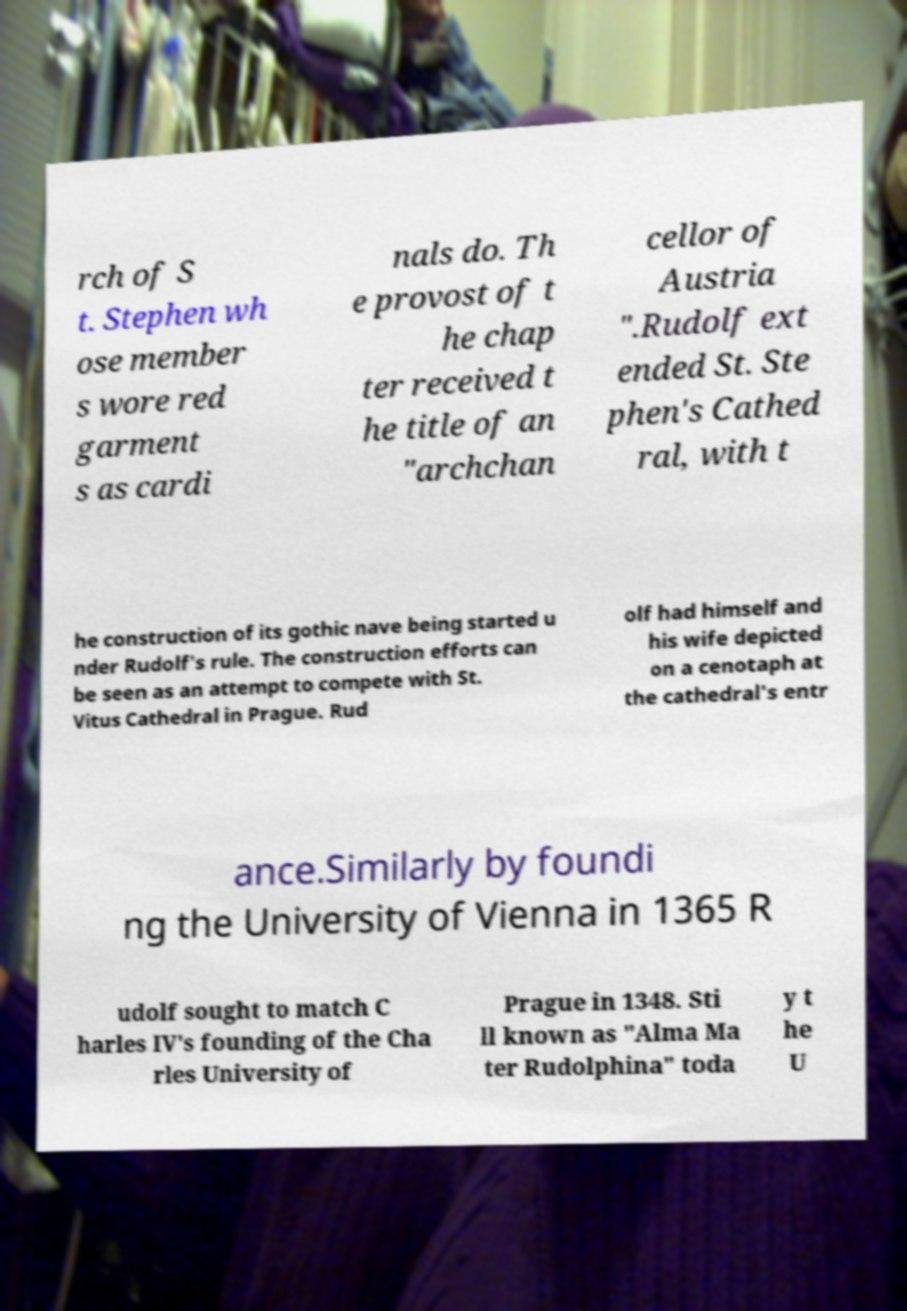There's text embedded in this image that I need extracted. Can you transcribe it verbatim? rch of S t. Stephen wh ose member s wore red garment s as cardi nals do. Th e provost of t he chap ter received t he title of an "archchan cellor of Austria ".Rudolf ext ended St. Ste phen's Cathed ral, with t he construction of its gothic nave being started u nder Rudolf's rule. The construction efforts can be seen as an attempt to compete with St. Vitus Cathedral in Prague. Rud olf had himself and his wife depicted on a cenotaph at the cathedral's entr ance.Similarly by foundi ng the University of Vienna in 1365 R udolf sought to match C harles IV's founding of the Cha rles University of Prague in 1348. Sti ll known as "Alma Ma ter Rudolphina" toda y t he U 